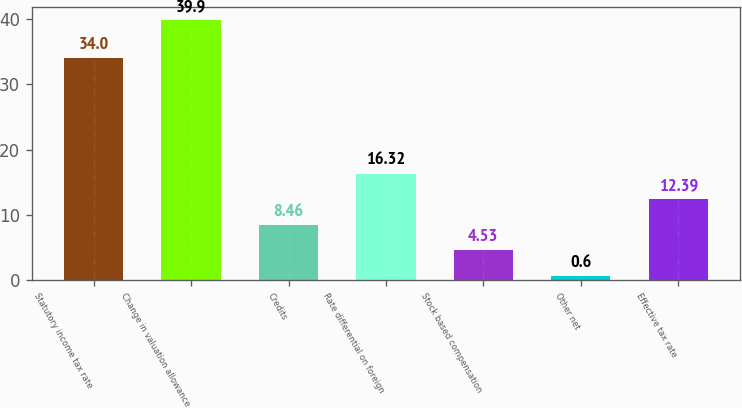Convert chart. <chart><loc_0><loc_0><loc_500><loc_500><bar_chart><fcel>Statutory income tax rate<fcel>Change in valuation allowance<fcel>Credits<fcel>Rate differential on foreign<fcel>Stock based compensation<fcel>Other net<fcel>Effective tax rate<nl><fcel>34<fcel>39.9<fcel>8.46<fcel>16.32<fcel>4.53<fcel>0.6<fcel>12.39<nl></chart> 